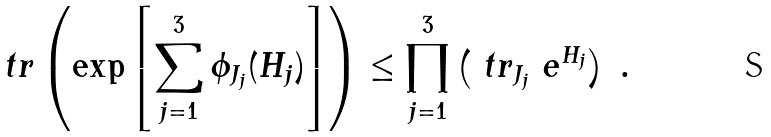Convert formula to latex. <formula><loc_0><loc_0><loc_500><loc_500>\ t r \left ( \exp \left [ \sum _ { j = 1 } ^ { 3 } \phi _ { J _ { j } } ( H _ { j } ) \right ] \right ) \leq \prod _ { j = 1 } ^ { 3 } \left ( \ t r _ { J _ { j } } \ e ^ { H _ { j } } \right ) \ .</formula> 